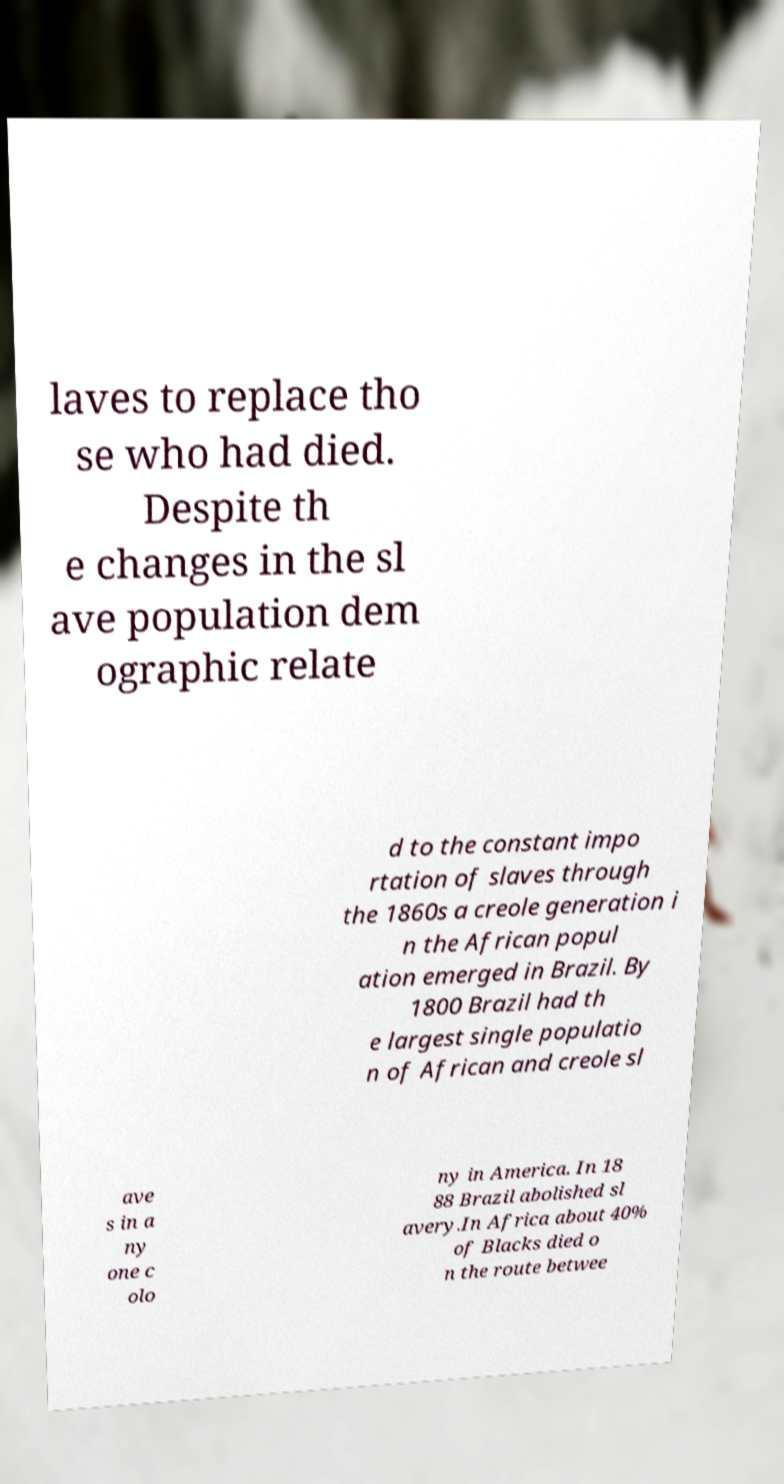For documentation purposes, I need the text within this image transcribed. Could you provide that? laves to replace tho se who had died. Despite th e changes in the sl ave population dem ographic relate d to the constant impo rtation of slaves through the 1860s a creole generation i n the African popul ation emerged in Brazil. By 1800 Brazil had th e largest single populatio n of African and creole sl ave s in a ny one c olo ny in America. In 18 88 Brazil abolished sl avery.In Africa about 40% of Blacks died o n the route betwee 